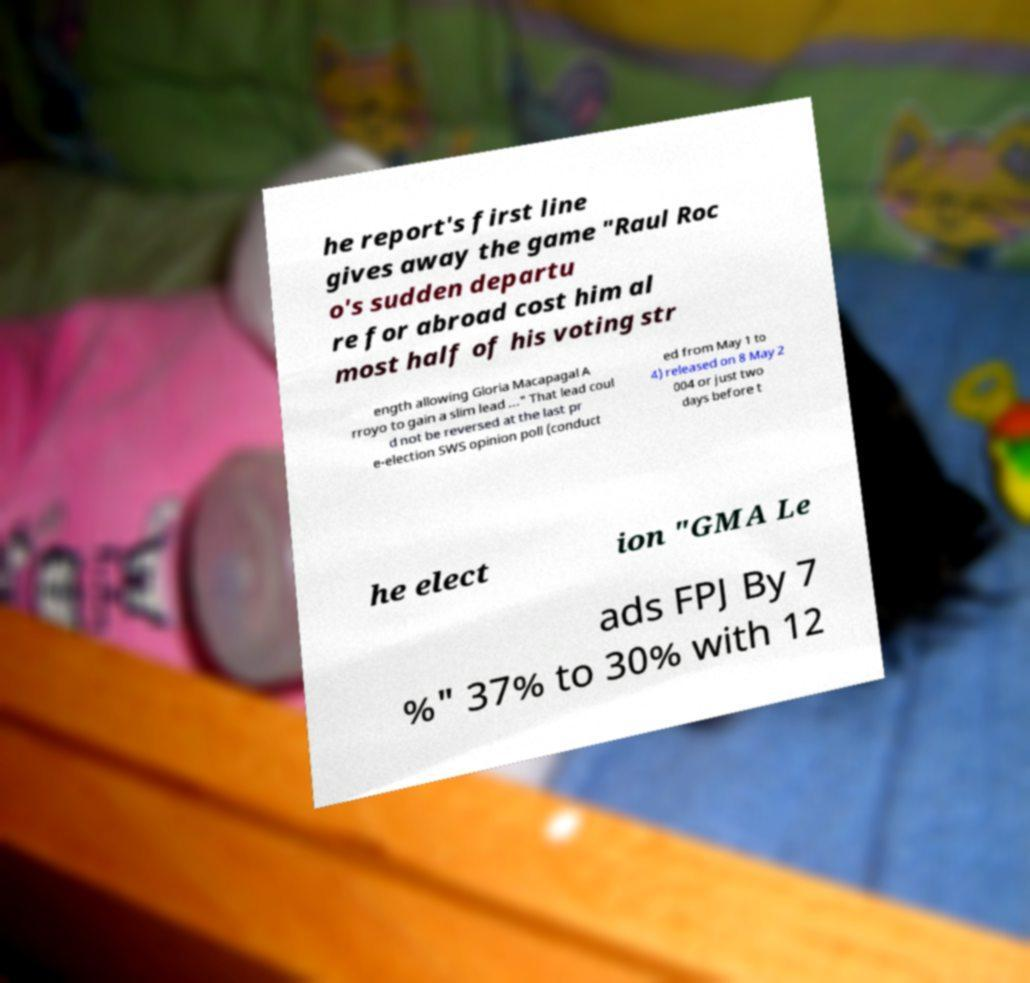Could you extract and type out the text from this image? he report's first line gives away the game "Raul Roc o's sudden departu re for abroad cost him al most half of his voting str ength allowing Gloria Macapagal A rroyo to gain a slim lead ..." That lead coul d not be reversed at the last pr e-election SWS opinion poll (conduct ed from May 1 to 4) released on 8 May 2 004 or just two days before t he elect ion "GMA Le ads FPJ By 7 %" 37% to 30% with 12 